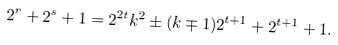Convert formula to latex. <formula><loc_0><loc_0><loc_500><loc_500>2 ^ { r } + 2 ^ { s } + 1 = 2 ^ { 2 t } k ^ { 2 } \pm ( k \mp 1 ) 2 ^ { t + 1 } + 2 ^ { t + 1 } + 1 .</formula> 